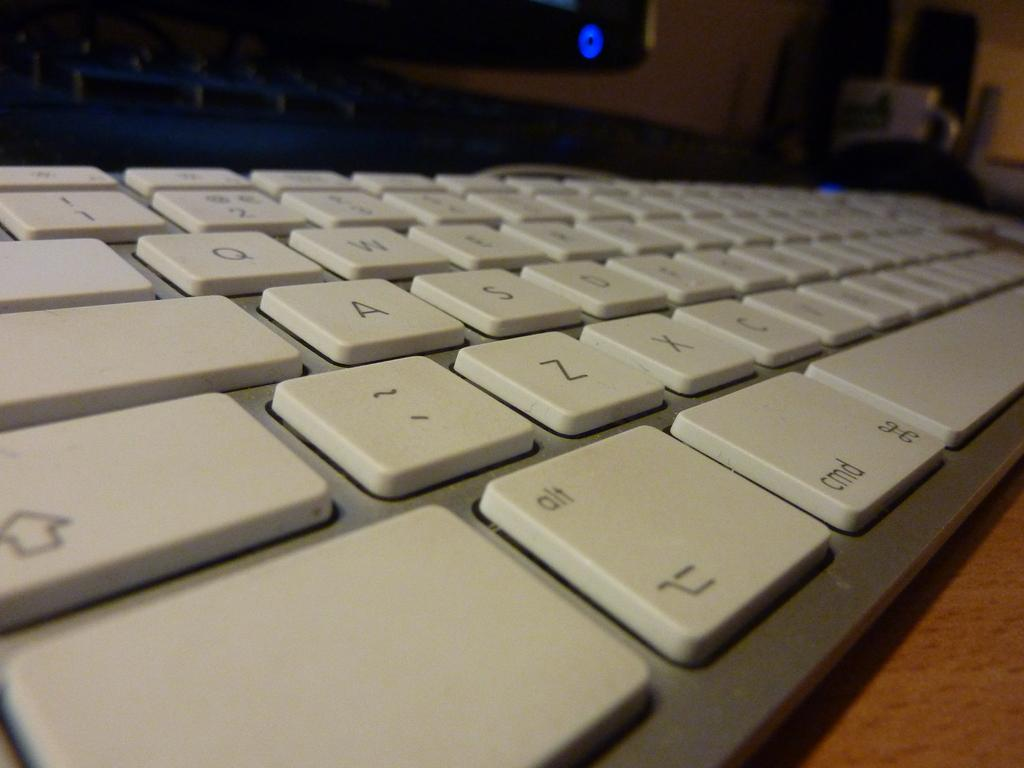<image>
Describe the image concisely. A keyboard showing keys such as alt and cmd 